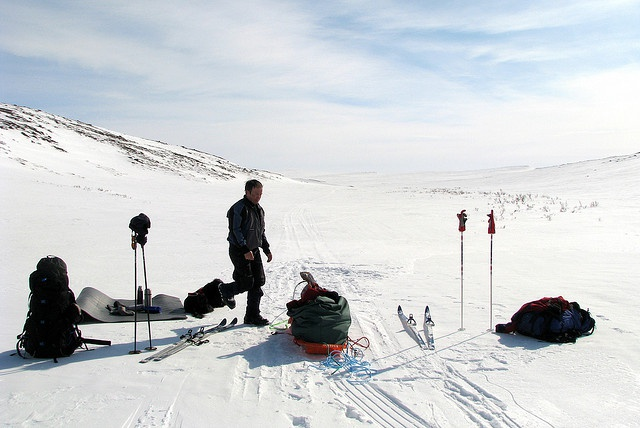Describe the objects in this image and their specific colors. I can see backpack in darkgray, black, white, and gray tones, people in darkgray, black, gray, maroon, and white tones, backpack in darkgray, black, gray, and maroon tones, backpack in darkgray, black, maroon, navy, and gray tones, and skis in darkgray, gray, black, and lightgray tones in this image. 